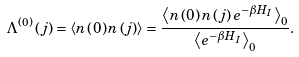Convert formula to latex. <formula><loc_0><loc_0><loc_500><loc_500>\Lambda ^ { \left ( 0 \right ) } \left ( j \right ) = \left \langle n \left ( 0 \right ) n \left ( j \right ) \right \rangle = \frac { \left \langle n \left ( 0 \right ) n \left ( j \right ) e ^ { - \beta H _ { I } } \right \rangle _ { 0 } } { \left \langle e ^ { - \beta H _ { I } } \right \rangle _ { 0 } } .</formula> 